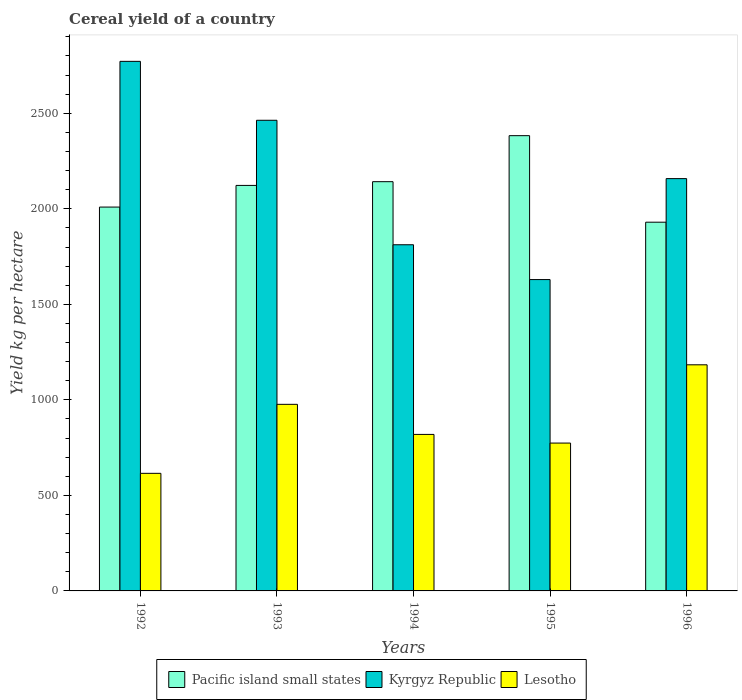How many different coloured bars are there?
Offer a very short reply. 3. Are the number of bars per tick equal to the number of legend labels?
Make the answer very short. Yes. Are the number of bars on each tick of the X-axis equal?
Make the answer very short. Yes. How many bars are there on the 3rd tick from the left?
Ensure brevity in your answer.  3. In how many cases, is the number of bars for a given year not equal to the number of legend labels?
Provide a short and direct response. 0. What is the total cereal yield in Kyrgyz Republic in 1992?
Your answer should be very brief. 2771.97. Across all years, what is the maximum total cereal yield in Lesotho?
Your answer should be compact. 1183.58. Across all years, what is the minimum total cereal yield in Kyrgyz Republic?
Ensure brevity in your answer.  1629.74. In which year was the total cereal yield in Kyrgyz Republic maximum?
Your answer should be very brief. 1992. What is the total total cereal yield in Lesotho in the graph?
Your answer should be compact. 4368.9. What is the difference between the total cereal yield in Kyrgyz Republic in 1995 and that in 1996?
Give a very brief answer. -528.44. What is the difference between the total cereal yield in Lesotho in 1992 and the total cereal yield in Kyrgyz Republic in 1996?
Your answer should be very brief. -1542.68. What is the average total cereal yield in Kyrgyz Republic per year?
Ensure brevity in your answer.  2167.08. In the year 1993, what is the difference between the total cereal yield in Pacific island small states and total cereal yield in Kyrgyz Republic?
Your answer should be very brief. -341.01. What is the ratio of the total cereal yield in Pacific island small states in 1993 to that in 1994?
Provide a short and direct response. 0.99. What is the difference between the highest and the second highest total cereal yield in Kyrgyz Republic?
Make the answer very short. 308.38. What is the difference between the highest and the lowest total cereal yield in Kyrgyz Republic?
Keep it short and to the point. 1142.24. Is the sum of the total cereal yield in Kyrgyz Republic in 1994 and 1995 greater than the maximum total cereal yield in Pacific island small states across all years?
Your response must be concise. Yes. What does the 2nd bar from the left in 1993 represents?
Your answer should be very brief. Kyrgyz Republic. What does the 3rd bar from the right in 1993 represents?
Make the answer very short. Pacific island small states. How many years are there in the graph?
Your response must be concise. 5. What is the difference between two consecutive major ticks on the Y-axis?
Give a very brief answer. 500. Does the graph contain any zero values?
Your answer should be very brief. No. Does the graph contain grids?
Offer a very short reply. No. Where does the legend appear in the graph?
Offer a very short reply. Bottom center. How many legend labels are there?
Offer a terse response. 3. How are the legend labels stacked?
Your answer should be very brief. Horizontal. What is the title of the graph?
Ensure brevity in your answer.  Cereal yield of a country. Does "Mali" appear as one of the legend labels in the graph?
Your response must be concise. No. What is the label or title of the X-axis?
Give a very brief answer. Years. What is the label or title of the Y-axis?
Ensure brevity in your answer.  Yield kg per hectare. What is the Yield kg per hectare of Pacific island small states in 1992?
Provide a succinct answer. 2009.23. What is the Yield kg per hectare in Kyrgyz Republic in 1992?
Ensure brevity in your answer.  2771.97. What is the Yield kg per hectare of Lesotho in 1992?
Make the answer very short. 615.5. What is the Yield kg per hectare in Pacific island small states in 1993?
Provide a succinct answer. 2122.58. What is the Yield kg per hectare in Kyrgyz Republic in 1993?
Give a very brief answer. 2463.59. What is the Yield kg per hectare in Lesotho in 1993?
Your response must be concise. 976.65. What is the Yield kg per hectare of Pacific island small states in 1994?
Your answer should be compact. 2142.14. What is the Yield kg per hectare of Kyrgyz Republic in 1994?
Give a very brief answer. 1811.92. What is the Yield kg per hectare in Lesotho in 1994?
Offer a terse response. 819.24. What is the Yield kg per hectare in Pacific island small states in 1995?
Keep it short and to the point. 2382.99. What is the Yield kg per hectare in Kyrgyz Republic in 1995?
Provide a short and direct response. 1629.74. What is the Yield kg per hectare in Lesotho in 1995?
Your answer should be compact. 773.93. What is the Yield kg per hectare of Pacific island small states in 1996?
Ensure brevity in your answer.  1930.07. What is the Yield kg per hectare of Kyrgyz Republic in 1996?
Your response must be concise. 2158.18. What is the Yield kg per hectare in Lesotho in 1996?
Make the answer very short. 1183.58. Across all years, what is the maximum Yield kg per hectare in Pacific island small states?
Keep it short and to the point. 2382.99. Across all years, what is the maximum Yield kg per hectare in Kyrgyz Republic?
Give a very brief answer. 2771.97. Across all years, what is the maximum Yield kg per hectare of Lesotho?
Your response must be concise. 1183.58. Across all years, what is the minimum Yield kg per hectare of Pacific island small states?
Ensure brevity in your answer.  1930.07. Across all years, what is the minimum Yield kg per hectare of Kyrgyz Republic?
Your answer should be very brief. 1629.74. Across all years, what is the minimum Yield kg per hectare in Lesotho?
Keep it short and to the point. 615.5. What is the total Yield kg per hectare of Pacific island small states in the graph?
Make the answer very short. 1.06e+04. What is the total Yield kg per hectare of Kyrgyz Republic in the graph?
Your response must be concise. 1.08e+04. What is the total Yield kg per hectare of Lesotho in the graph?
Keep it short and to the point. 4368.9. What is the difference between the Yield kg per hectare in Pacific island small states in 1992 and that in 1993?
Provide a succinct answer. -113.35. What is the difference between the Yield kg per hectare of Kyrgyz Republic in 1992 and that in 1993?
Provide a succinct answer. 308.38. What is the difference between the Yield kg per hectare in Lesotho in 1992 and that in 1993?
Offer a terse response. -361.15. What is the difference between the Yield kg per hectare of Pacific island small states in 1992 and that in 1994?
Your answer should be compact. -132.91. What is the difference between the Yield kg per hectare of Kyrgyz Republic in 1992 and that in 1994?
Provide a succinct answer. 960.05. What is the difference between the Yield kg per hectare of Lesotho in 1992 and that in 1994?
Offer a very short reply. -203.74. What is the difference between the Yield kg per hectare of Pacific island small states in 1992 and that in 1995?
Give a very brief answer. -373.76. What is the difference between the Yield kg per hectare in Kyrgyz Republic in 1992 and that in 1995?
Your response must be concise. 1142.24. What is the difference between the Yield kg per hectare of Lesotho in 1992 and that in 1995?
Your answer should be compact. -158.43. What is the difference between the Yield kg per hectare of Pacific island small states in 1992 and that in 1996?
Your answer should be very brief. 79.16. What is the difference between the Yield kg per hectare of Kyrgyz Republic in 1992 and that in 1996?
Make the answer very short. 613.79. What is the difference between the Yield kg per hectare of Lesotho in 1992 and that in 1996?
Ensure brevity in your answer.  -568.08. What is the difference between the Yield kg per hectare of Pacific island small states in 1993 and that in 1994?
Ensure brevity in your answer.  -19.56. What is the difference between the Yield kg per hectare of Kyrgyz Republic in 1993 and that in 1994?
Make the answer very short. 651.67. What is the difference between the Yield kg per hectare of Lesotho in 1993 and that in 1994?
Offer a terse response. 157.41. What is the difference between the Yield kg per hectare of Pacific island small states in 1993 and that in 1995?
Offer a terse response. -260.41. What is the difference between the Yield kg per hectare of Kyrgyz Republic in 1993 and that in 1995?
Offer a very short reply. 833.85. What is the difference between the Yield kg per hectare of Lesotho in 1993 and that in 1995?
Provide a short and direct response. 202.72. What is the difference between the Yield kg per hectare of Pacific island small states in 1993 and that in 1996?
Your answer should be very brief. 192.52. What is the difference between the Yield kg per hectare in Kyrgyz Republic in 1993 and that in 1996?
Provide a short and direct response. 305.41. What is the difference between the Yield kg per hectare of Lesotho in 1993 and that in 1996?
Give a very brief answer. -206.93. What is the difference between the Yield kg per hectare in Pacific island small states in 1994 and that in 1995?
Keep it short and to the point. -240.85. What is the difference between the Yield kg per hectare of Kyrgyz Republic in 1994 and that in 1995?
Your answer should be compact. 182.19. What is the difference between the Yield kg per hectare of Lesotho in 1994 and that in 1995?
Offer a terse response. 45.31. What is the difference between the Yield kg per hectare of Pacific island small states in 1994 and that in 1996?
Your answer should be compact. 212.07. What is the difference between the Yield kg per hectare of Kyrgyz Republic in 1994 and that in 1996?
Offer a terse response. -346.25. What is the difference between the Yield kg per hectare in Lesotho in 1994 and that in 1996?
Offer a terse response. -364.34. What is the difference between the Yield kg per hectare of Pacific island small states in 1995 and that in 1996?
Provide a short and direct response. 452.92. What is the difference between the Yield kg per hectare in Kyrgyz Republic in 1995 and that in 1996?
Your answer should be very brief. -528.44. What is the difference between the Yield kg per hectare of Lesotho in 1995 and that in 1996?
Your response must be concise. -409.65. What is the difference between the Yield kg per hectare of Pacific island small states in 1992 and the Yield kg per hectare of Kyrgyz Republic in 1993?
Offer a very short reply. -454.36. What is the difference between the Yield kg per hectare of Pacific island small states in 1992 and the Yield kg per hectare of Lesotho in 1993?
Provide a succinct answer. 1032.58. What is the difference between the Yield kg per hectare of Kyrgyz Republic in 1992 and the Yield kg per hectare of Lesotho in 1993?
Offer a very short reply. 1795.32. What is the difference between the Yield kg per hectare in Pacific island small states in 1992 and the Yield kg per hectare in Kyrgyz Republic in 1994?
Ensure brevity in your answer.  197.3. What is the difference between the Yield kg per hectare in Pacific island small states in 1992 and the Yield kg per hectare in Lesotho in 1994?
Provide a succinct answer. 1189.99. What is the difference between the Yield kg per hectare in Kyrgyz Republic in 1992 and the Yield kg per hectare in Lesotho in 1994?
Provide a succinct answer. 1952.73. What is the difference between the Yield kg per hectare of Pacific island small states in 1992 and the Yield kg per hectare of Kyrgyz Republic in 1995?
Keep it short and to the point. 379.49. What is the difference between the Yield kg per hectare of Pacific island small states in 1992 and the Yield kg per hectare of Lesotho in 1995?
Offer a very short reply. 1235.3. What is the difference between the Yield kg per hectare of Kyrgyz Republic in 1992 and the Yield kg per hectare of Lesotho in 1995?
Your response must be concise. 1998.04. What is the difference between the Yield kg per hectare of Pacific island small states in 1992 and the Yield kg per hectare of Kyrgyz Republic in 1996?
Your response must be concise. -148.95. What is the difference between the Yield kg per hectare in Pacific island small states in 1992 and the Yield kg per hectare in Lesotho in 1996?
Offer a very short reply. 825.65. What is the difference between the Yield kg per hectare in Kyrgyz Republic in 1992 and the Yield kg per hectare in Lesotho in 1996?
Your response must be concise. 1588.39. What is the difference between the Yield kg per hectare of Pacific island small states in 1993 and the Yield kg per hectare of Kyrgyz Republic in 1994?
Offer a very short reply. 310.66. What is the difference between the Yield kg per hectare in Pacific island small states in 1993 and the Yield kg per hectare in Lesotho in 1994?
Make the answer very short. 1303.34. What is the difference between the Yield kg per hectare of Kyrgyz Republic in 1993 and the Yield kg per hectare of Lesotho in 1994?
Ensure brevity in your answer.  1644.35. What is the difference between the Yield kg per hectare of Pacific island small states in 1993 and the Yield kg per hectare of Kyrgyz Republic in 1995?
Your answer should be compact. 492.85. What is the difference between the Yield kg per hectare of Pacific island small states in 1993 and the Yield kg per hectare of Lesotho in 1995?
Provide a succinct answer. 1348.65. What is the difference between the Yield kg per hectare of Kyrgyz Republic in 1993 and the Yield kg per hectare of Lesotho in 1995?
Your answer should be compact. 1689.66. What is the difference between the Yield kg per hectare of Pacific island small states in 1993 and the Yield kg per hectare of Kyrgyz Republic in 1996?
Provide a succinct answer. -35.6. What is the difference between the Yield kg per hectare of Pacific island small states in 1993 and the Yield kg per hectare of Lesotho in 1996?
Provide a short and direct response. 939. What is the difference between the Yield kg per hectare in Kyrgyz Republic in 1993 and the Yield kg per hectare in Lesotho in 1996?
Keep it short and to the point. 1280.01. What is the difference between the Yield kg per hectare of Pacific island small states in 1994 and the Yield kg per hectare of Kyrgyz Republic in 1995?
Give a very brief answer. 512.4. What is the difference between the Yield kg per hectare in Pacific island small states in 1994 and the Yield kg per hectare in Lesotho in 1995?
Make the answer very short. 1368.21. What is the difference between the Yield kg per hectare in Kyrgyz Republic in 1994 and the Yield kg per hectare in Lesotho in 1995?
Offer a very short reply. 1037.99. What is the difference between the Yield kg per hectare of Pacific island small states in 1994 and the Yield kg per hectare of Kyrgyz Republic in 1996?
Ensure brevity in your answer.  -16.04. What is the difference between the Yield kg per hectare in Pacific island small states in 1994 and the Yield kg per hectare in Lesotho in 1996?
Keep it short and to the point. 958.56. What is the difference between the Yield kg per hectare in Kyrgyz Republic in 1994 and the Yield kg per hectare in Lesotho in 1996?
Keep it short and to the point. 628.34. What is the difference between the Yield kg per hectare in Pacific island small states in 1995 and the Yield kg per hectare in Kyrgyz Republic in 1996?
Provide a short and direct response. 224.81. What is the difference between the Yield kg per hectare in Pacific island small states in 1995 and the Yield kg per hectare in Lesotho in 1996?
Your answer should be very brief. 1199.41. What is the difference between the Yield kg per hectare of Kyrgyz Republic in 1995 and the Yield kg per hectare of Lesotho in 1996?
Your answer should be very brief. 446.16. What is the average Yield kg per hectare of Pacific island small states per year?
Keep it short and to the point. 2117.4. What is the average Yield kg per hectare in Kyrgyz Republic per year?
Provide a succinct answer. 2167.08. What is the average Yield kg per hectare in Lesotho per year?
Give a very brief answer. 873.78. In the year 1992, what is the difference between the Yield kg per hectare in Pacific island small states and Yield kg per hectare in Kyrgyz Republic?
Your answer should be compact. -762.74. In the year 1992, what is the difference between the Yield kg per hectare in Pacific island small states and Yield kg per hectare in Lesotho?
Your response must be concise. 1393.73. In the year 1992, what is the difference between the Yield kg per hectare of Kyrgyz Republic and Yield kg per hectare of Lesotho?
Offer a very short reply. 2156.47. In the year 1993, what is the difference between the Yield kg per hectare in Pacific island small states and Yield kg per hectare in Kyrgyz Republic?
Ensure brevity in your answer.  -341.01. In the year 1993, what is the difference between the Yield kg per hectare of Pacific island small states and Yield kg per hectare of Lesotho?
Provide a succinct answer. 1145.93. In the year 1993, what is the difference between the Yield kg per hectare in Kyrgyz Republic and Yield kg per hectare in Lesotho?
Your answer should be very brief. 1486.94. In the year 1994, what is the difference between the Yield kg per hectare of Pacific island small states and Yield kg per hectare of Kyrgyz Republic?
Provide a succinct answer. 330.22. In the year 1994, what is the difference between the Yield kg per hectare of Pacific island small states and Yield kg per hectare of Lesotho?
Provide a succinct answer. 1322.9. In the year 1994, what is the difference between the Yield kg per hectare of Kyrgyz Republic and Yield kg per hectare of Lesotho?
Your answer should be compact. 992.68. In the year 1995, what is the difference between the Yield kg per hectare in Pacific island small states and Yield kg per hectare in Kyrgyz Republic?
Provide a short and direct response. 753.25. In the year 1995, what is the difference between the Yield kg per hectare in Pacific island small states and Yield kg per hectare in Lesotho?
Your answer should be compact. 1609.06. In the year 1995, what is the difference between the Yield kg per hectare in Kyrgyz Republic and Yield kg per hectare in Lesotho?
Ensure brevity in your answer.  855.8. In the year 1996, what is the difference between the Yield kg per hectare of Pacific island small states and Yield kg per hectare of Kyrgyz Republic?
Your response must be concise. -228.11. In the year 1996, what is the difference between the Yield kg per hectare in Pacific island small states and Yield kg per hectare in Lesotho?
Give a very brief answer. 746.49. In the year 1996, what is the difference between the Yield kg per hectare in Kyrgyz Republic and Yield kg per hectare in Lesotho?
Your answer should be very brief. 974.6. What is the ratio of the Yield kg per hectare of Pacific island small states in 1992 to that in 1993?
Offer a very short reply. 0.95. What is the ratio of the Yield kg per hectare in Kyrgyz Republic in 1992 to that in 1993?
Your answer should be compact. 1.13. What is the ratio of the Yield kg per hectare of Lesotho in 1992 to that in 1993?
Make the answer very short. 0.63. What is the ratio of the Yield kg per hectare in Pacific island small states in 1992 to that in 1994?
Make the answer very short. 0.94. What is the ratio of the Yield kg per hectare of Kyrgyz Republic in 1992 to that in 1994?
Make the answer very short. 1.53. What is the ratio of the Yield kg per hectare in Lesotho in 1992 to that in 1994?
Give a very brief answer. 0.75. What is the ratio of the Yield kg per hectare of Pacific island small states in 1992 to that in 1995?
Ensure brevity in your answer.  0.84. What is the ratio of the Yield kg per hectare of Kyrgyz Republic in 1992 to that in 1995?
Make the answer very short. 1.7. What is the ratio of the Yield kg per hectare in Lesotho in 1992 to that in 1995?
Provide a short and direct response. 0.8. What is the ratio of the Yield kg per hectare in Pacific island small states in 1992 to that in 1996?
Give a very brief answer. 1.04. What is the ratio of the Yield kg per hectare in Kyrgyz Republic in 1992 to that in 1996?
Make the answer very short. 1.28. What is the ratio of the Yield kg per hectare in Lesotho in 1992 to that in 1996?
Your answer should be compact. 0.52. What is the ratio of the Yield kg per hectare of Pacific island small states in 1993 to that in 1994?
Provide a short and direct response. 0.99. What is the ratio of the Yield kg per hectare of Kyrgyz Republic in 1993 to that in 1994?
Give a very brief answer. 1.36. What is the ratio of the Yield kg per hectare of Lesotho in 1993 to that in 1994?
Offer a very short reply. 1.19. What is the ratio of the Yield kg per hectare in Pacific island small states in 1993 to that in 1995?
Provide a short and direct response. 0.89. What is the ratio of the Yield kg per hectare of Kyrgyz Republic in 1993 to that in 1995?
Ensure brevity in your answer.  1.51. What is the ratio of the Yield kg per hectare in Lesotho in 1993 to that in 1995?
Your answer should be compact. 1.26. What is the ratio of the Yield kg per hectare in Pacific island small states in 1993 to that in 1996?
Give a very brief answer. 1.1. What is the ratio of the Yield kg per hectare of Kyrgyz Republic in 1993 to that in 1996?
Keep it short and to the point. 1.14. What is the ratio of the Yield kg per hectare of Lesotho in 1993 to that in 1996?
Offer a very short reply. 0.83. What is the ratio of the Yield kg per hectare in Pacific island small states in 1994 to that in 1995?
Give a very brief answer. 0.9. What is the ratio of the Yield kg per hectare in Kyrgyz Republic in 1994 to that in 1995?
Ensure brevity in your answer.  1.11. What is the ratio of the Yield kg per hectare of Lesotho in 1994 to that in 1995?
Your answer should be very brief. 1.06. What is the ratio of the Yield kg per hectare of Pacific island small states in 1994 to that in 1996?
Keep it short and to the point. 1.11. What is the ratio of the Yield kg per hectare in Kyrgyz Republic in 1994 to that in 1996?
Make the answer very short. 0.84. What is the ratio of the Yield kg per hectare in Lesotho in 1994 to that in 1996?
Your answer should be compact. 0.69. What is the ratio of the Yield kg per hectare in Pacific island small states in 1995 to that in 1996?
Your response must be concise. 1.23. What is the ratio of the Yield kg per hectare of Kyrgyz Republic in 1995 to that in 1996?
Offer a very short reply. 0.76. What is the ratio of the Yield kg per hectare of Lesotho in 1995 to that in 1996?
Make the answer very short. 0.65. What is the difference between the highest and the second highest Yield kg per hectare of Pacific island small states?
Offer a very short reply. 240.85. What is the difference between the highest and the second highest Yield kg per hectare of Kyrgyz Republic?
Offer a very short reply. 308.38. What is the difference between the highest and the second highest Yield kg per hectare in Lesotho?
Give a very brief answer. 206.93. What is the difference between the highest and the lowest Yield kg per hectare in Pacific island small states?
Provide a succinct answer. 452.92. What is the difference between the highest and the lowest Yield kg per hectare of Kyrgyz Republic?
Offer a terse response. 1142.24. What is the difference between the highest and the lowest Yield kg per hectare in Lesotho?
Ensure brevity in your answer.  568.08. 